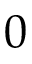<formula> <loc_0><loc_0><loc_500><loc_500>0</formula> 